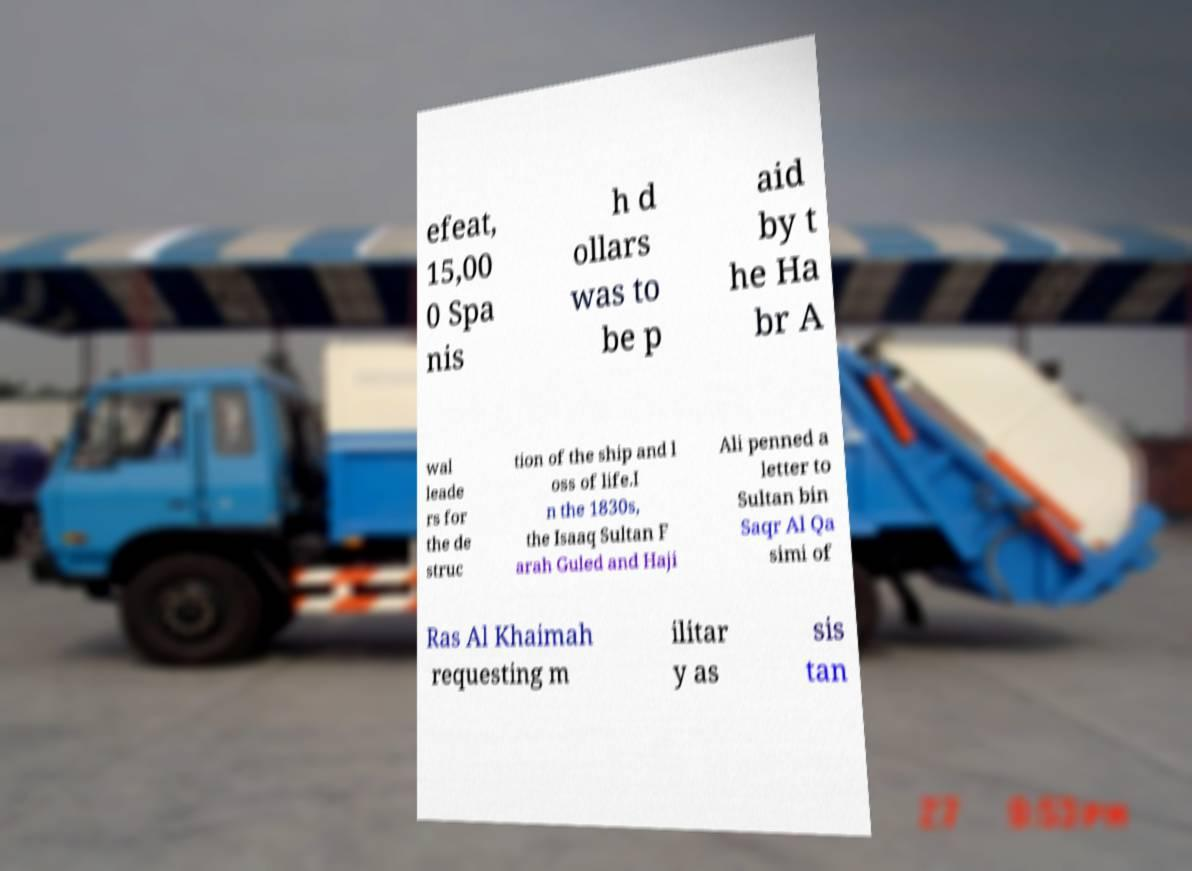For documentation purposes, I need the text within this image transcribed. Could you provide that? efeat, 15,00 0 Spa nis h d ollars was to be p aid by t he Ha br A wal leade rs for the de struc tion of the ship and l oss of life.I n the 1830s, the Isaaq Sultan F arah Guled and Haji Ali penned a letter to Sultan bin Saqr Al Qa simi of Ras Al Khaimah requesting m ilitar y as sis tan 